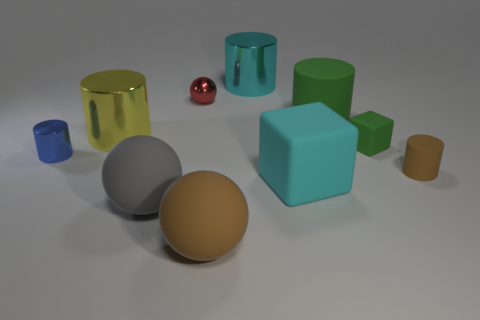How many rubber things are either blue balls or tiny green things?
Make the answer very short. 1. Is the number of big brown matte balls that are behind the large cyan rubber block the same as the number of big matte blocks?
Provide a short and direct response. No. Is the color of the big cylinder on the right side of the cyan rubber object the same as the small matte block?
Your response must be concise. Yes. There is a tiny thing that is both behind the tiny shiny cylinder and in front of the red ball; what material is it made of?
Offer a very short reply. Rubber. There is a green matte cube that is on the right side of the blue metal thing; is there a gray rubber object right of it?
Your answer should be compact. No. Is the material of the small red object the same as the tiny brown object?
Offer a very short reply. No. There is a big object that is both left of the large brown ball and behind the gray rubber object; what shape is it?
Offer a very short reply. Cylinder. There is a ball behind the rubber block that is in front of the tiny metallic cylinder; what size is it?
Provide a succinct answer. Small. What number of tiny red things have the same shape as the gray thing?
Give a very brief answer. 1. Is the small matte block the same color as the big matte cylinder?
Make the answer very short. Yes. 